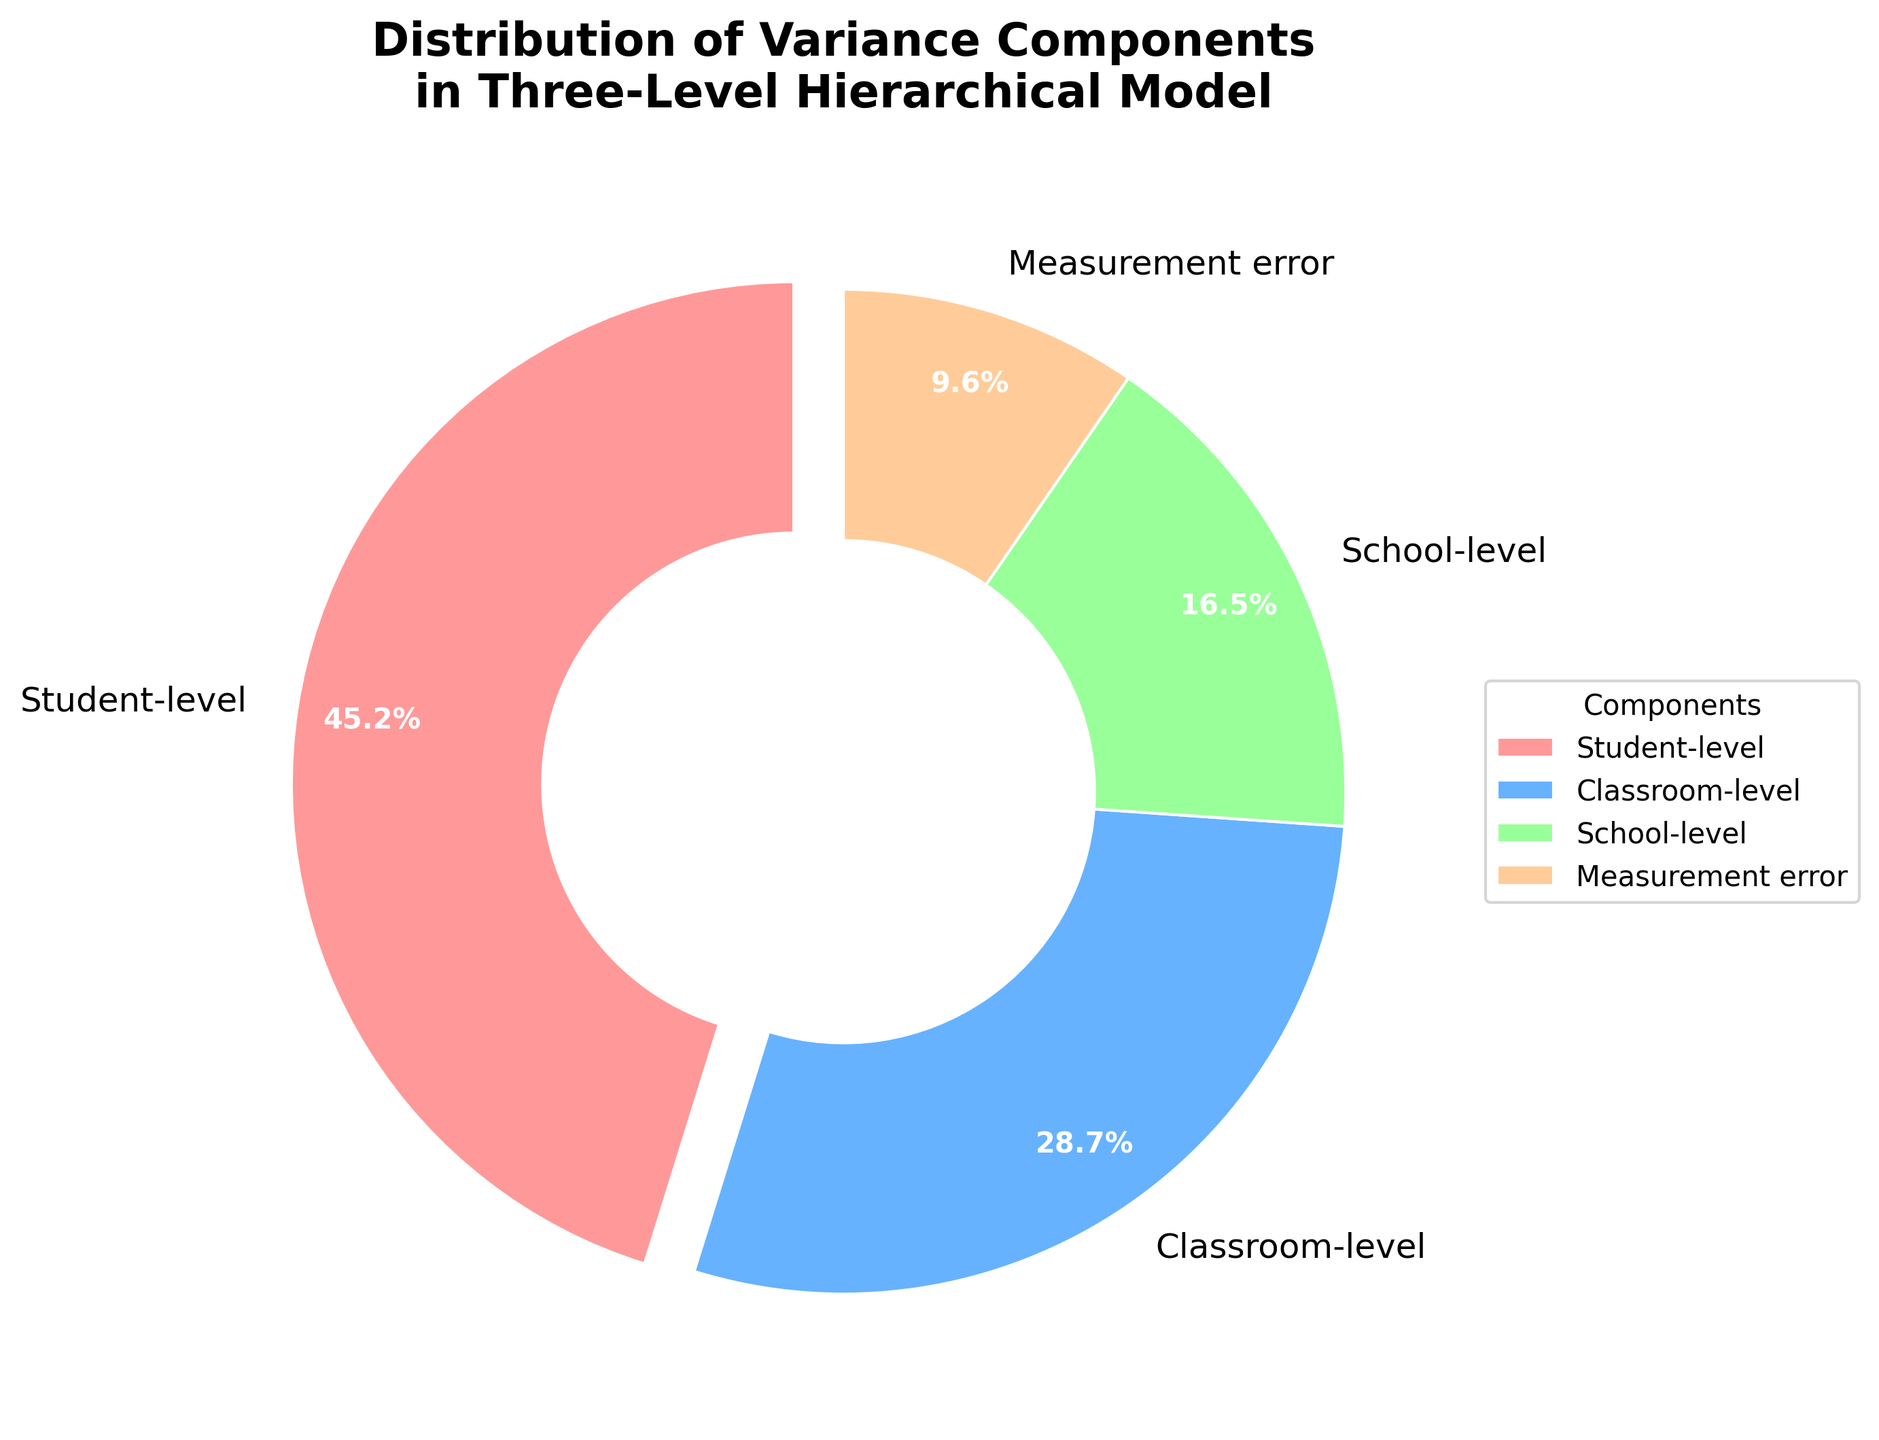What percentage of the variance is attributed to the Classroom-level component? The pie chart labels each component with its variance percentage. The label for the Classroom-level indicates it is responsible for 28.7% of the variance.
Answer: 28.7% Which component contributes the least to the total variance? By viewing the pie chart and comparing the sizes of the slices and their corresponding percentages, the Measurement error component at 9.6% is the smallest.
Answer: Measurement error How much more variance is attributed to the Student-level component compared to the School-level component? The Student-level component accounts for 45.2% of the variance, while the School-level component accounts for 16.5%. The difference is 45.2% - 16.5% = 28.7%.
Answer: 28.7% What is the total percentage of variance accounted for by Student-level and Measurement error components combined? Adding the percentages of Student-level (45.2%) and Measurement error (9.6%) gives 45.2% + 9.6% = 54.8%.
Answer: 54.8% What is the color associated with the School-level component? The visual representation shows the colors of each component. The School-level component is colored green.
Answer: green Which component has a wedge that is slightly separated (exploded) from the main pie? The visual feature of the pie chart indicates that the Student-level component’s wedge is slightly exploded, indicating its relative importance.
Answer: Student-level How much more variance is contributed by Classroom-level than by Measurement error? The Classroom-level accounts for 28.7% of the variance while Measurement error accounts for 9.6%. The difference is 28.7% - 9.6% = 19.1%.
Answer: 19.1% Which component occupies the largest slice of the pie chart? By comparing the slices in the pie chart, the Student-level component has the largest slice, indicating the highest percentage of variance at 45.2%.
Answer: Student-level What is the combined variance percentage of the Classroom-level and School-level components? Adding the percentages of Classroom-level (28.7%) and School-level (16.5%) gives 28.7% + 16.5% = 45.2%.
Answer: 45.2% Is the slice representing Student-level variance larger than the combined slices of Classroom-level and Measurement error? The Student-level variance is 45.2%. The combined variance of Classroom-level (28.7%) and Measurement error (9.6%) is 28.7% + 9.6% = 38.3%. Since 45.2% > 38.3%, Student-level is larger.
Answer: Yes 